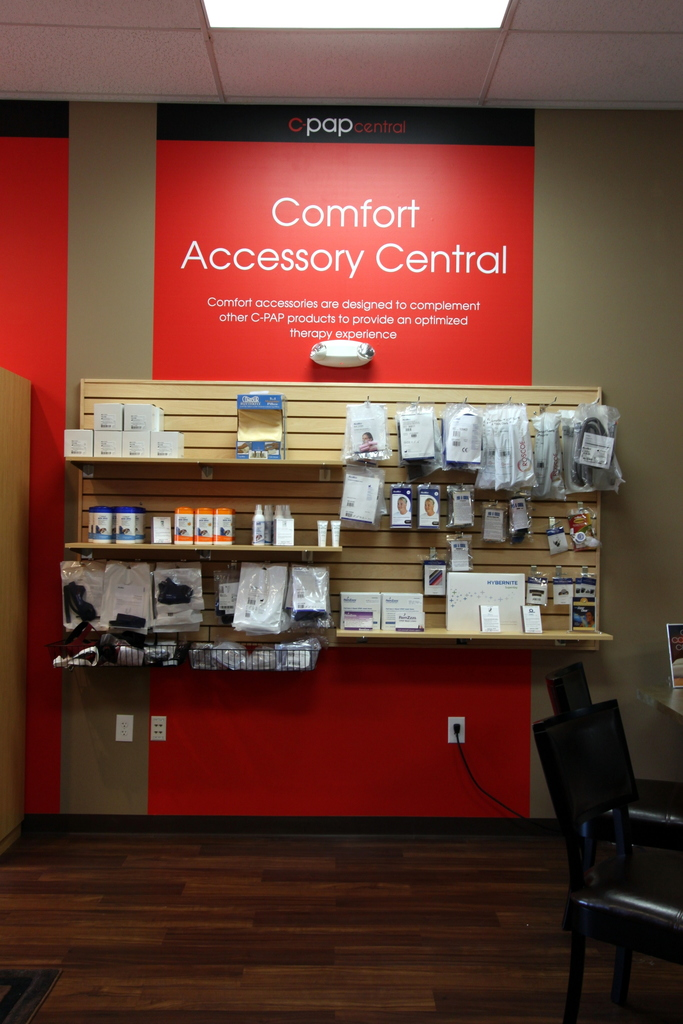How does the design of the store contribute to the shopper's experience? The store's design, with its clear labeling and organized presentation against a contrasting red background, makes it easy for shoppers to locate and understand the products, enhancing their shopping experience. Is there anything in the image that indicates how to gain more information or assistance about the products? Yes, there are informational brochures visible on the shelves, and a service desk that likely offers additional assistance is hinted at through the setup of the area with chairs for waiting or consultation. 